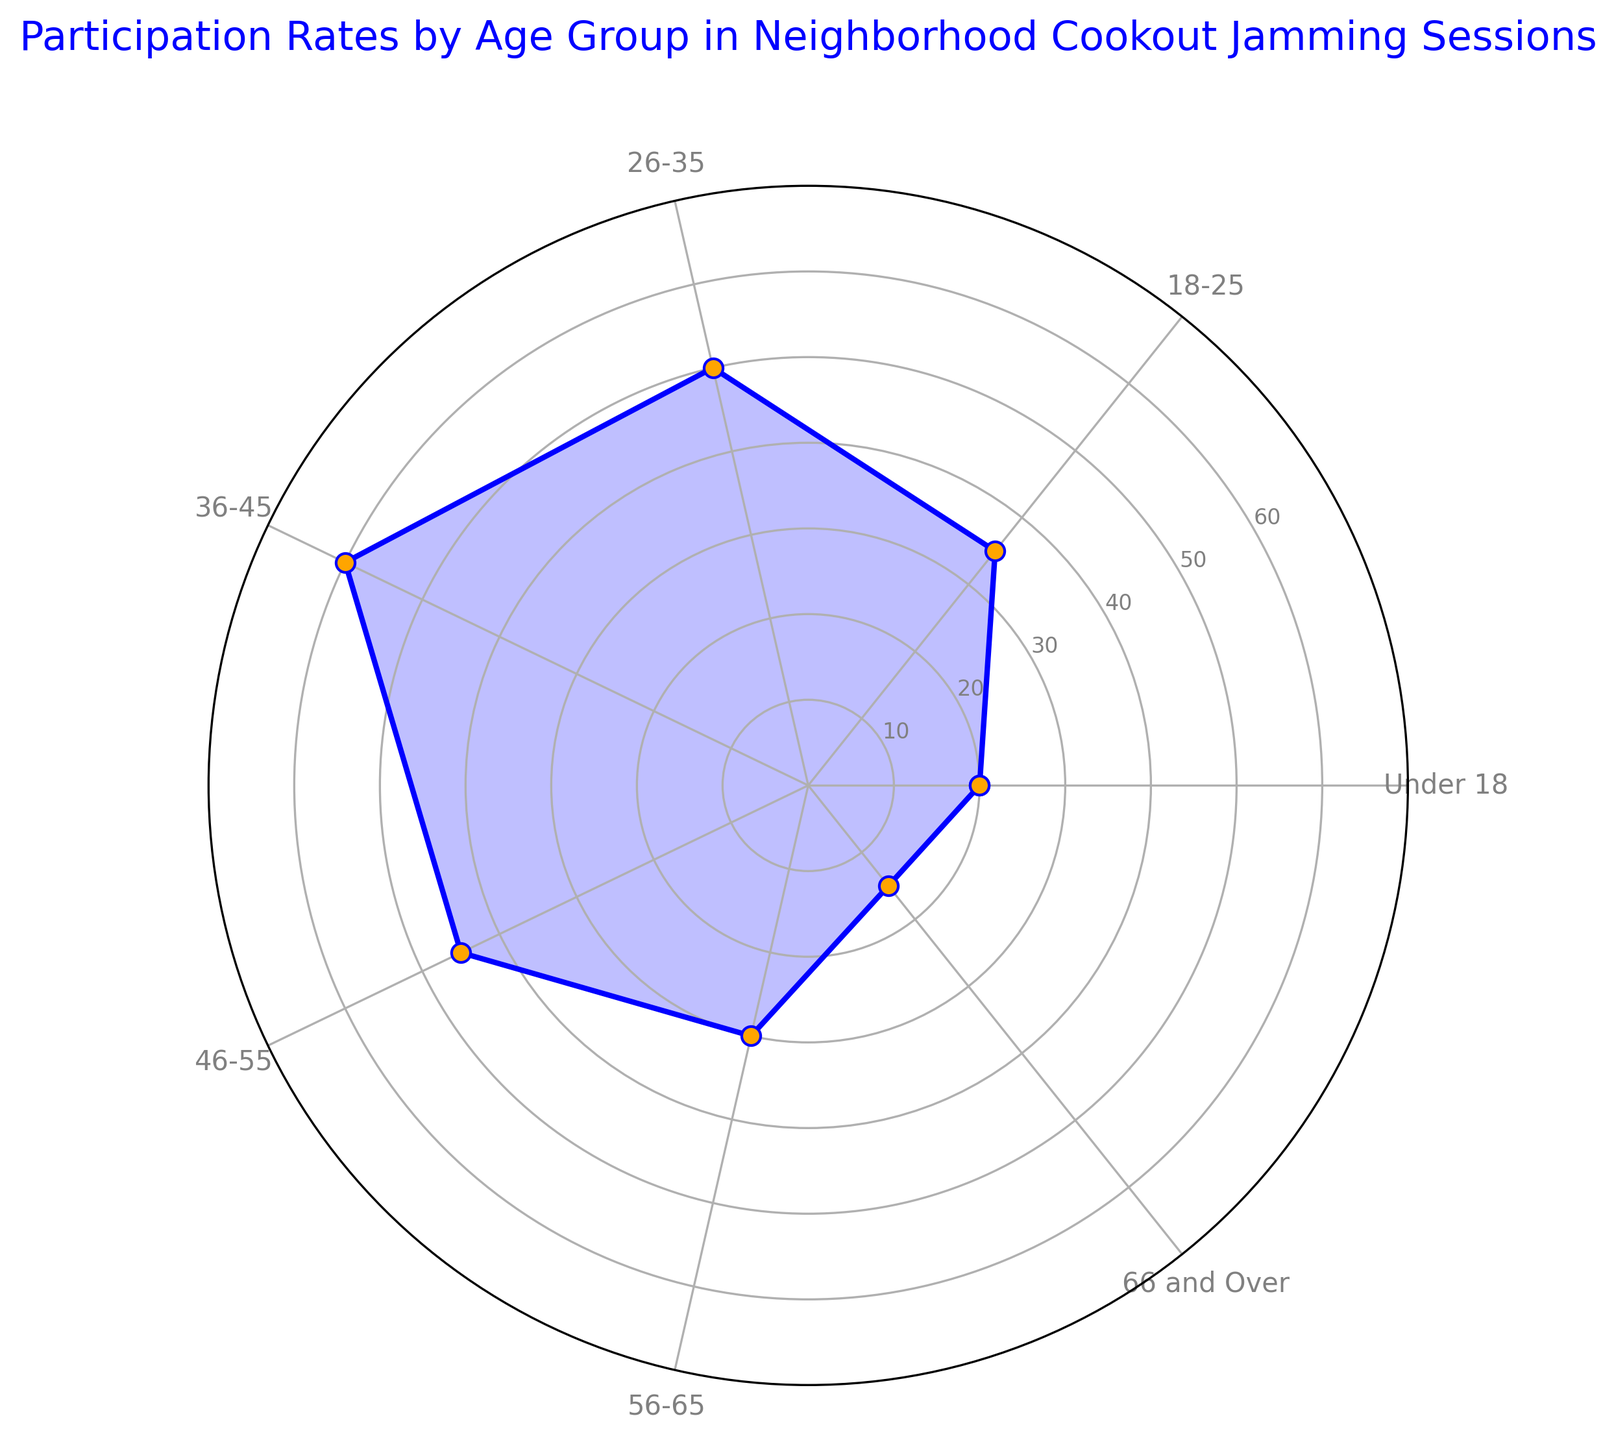What's the highest participation rate among the age groups? The radar chart shows that the 36-45 age group has the highest participation rate. This can be determined by looking at the peak value of 60 on the chart.
Answer: 60 Which age group has a lower participation rate: 18-25 or 56-65? By comparing the values on the radar chart, the 18-25 age group has a participation rate of 35, while the 56-65 age group has a rate of 30. Since 30 is less than 35, 56-65 has a lower participation rate.
Answer: 56-65 What is the range of participation rates across all age groups? The range is calculated by subtracting the lowest participation rate from the highest participation rate. The lowest participation rate is 15 (66 and Over) and the highest is 60 (36-45). Therefore, the range is 60 - 15 = 45.
Answer: 45 Which age groups have participation rates above the median rate? First, find the median value of the participation rates: 20, 30, 35, 45, 50, 60 (sorted order: 15, 20, 30, 35, 45, 50, 60). The median value is 35. The age groups with participation rates above 35 are 26-35 (50), 36-45 (60), and 46-55 (45).
Answer: 26-35, 36-45, 46-55 What is the cumulative participation rate of the age groups Under 18, 18-25, and 66 and Over? Sum of the participation rates for these age groups: Under 18 (20) + 18-25 (35) + 66 and Over (15) = 20 + 35 + 15 = 70.
Answer: 70 By how much does the participation rate of the 36-45 age group exceed that of the 66 and Over age group? The participation rate of the 36-45 age group is 60, and that of the 66 and Over age group is 15. The difference is 60 - 15 = 45.
Answer: 45 Which age group has the closest participation rate to 40? The participation rates close to 40 are for the age groups 18-25 (35) and 46-55 (45). Since 35 is closer to 40 than 45, the closest age group is 18-25.
Answer: 18-25 What is the average participation rate for all age groups? To find the average, sum up all participation rates and divide by the number of age groups. Sum = 20 + 35 + 50 + 60 + 45 + 30 + 15 = 255. Number of age groups = 7. Average = 255 / 7 ≈ 36.4.
Answer: 36.4 